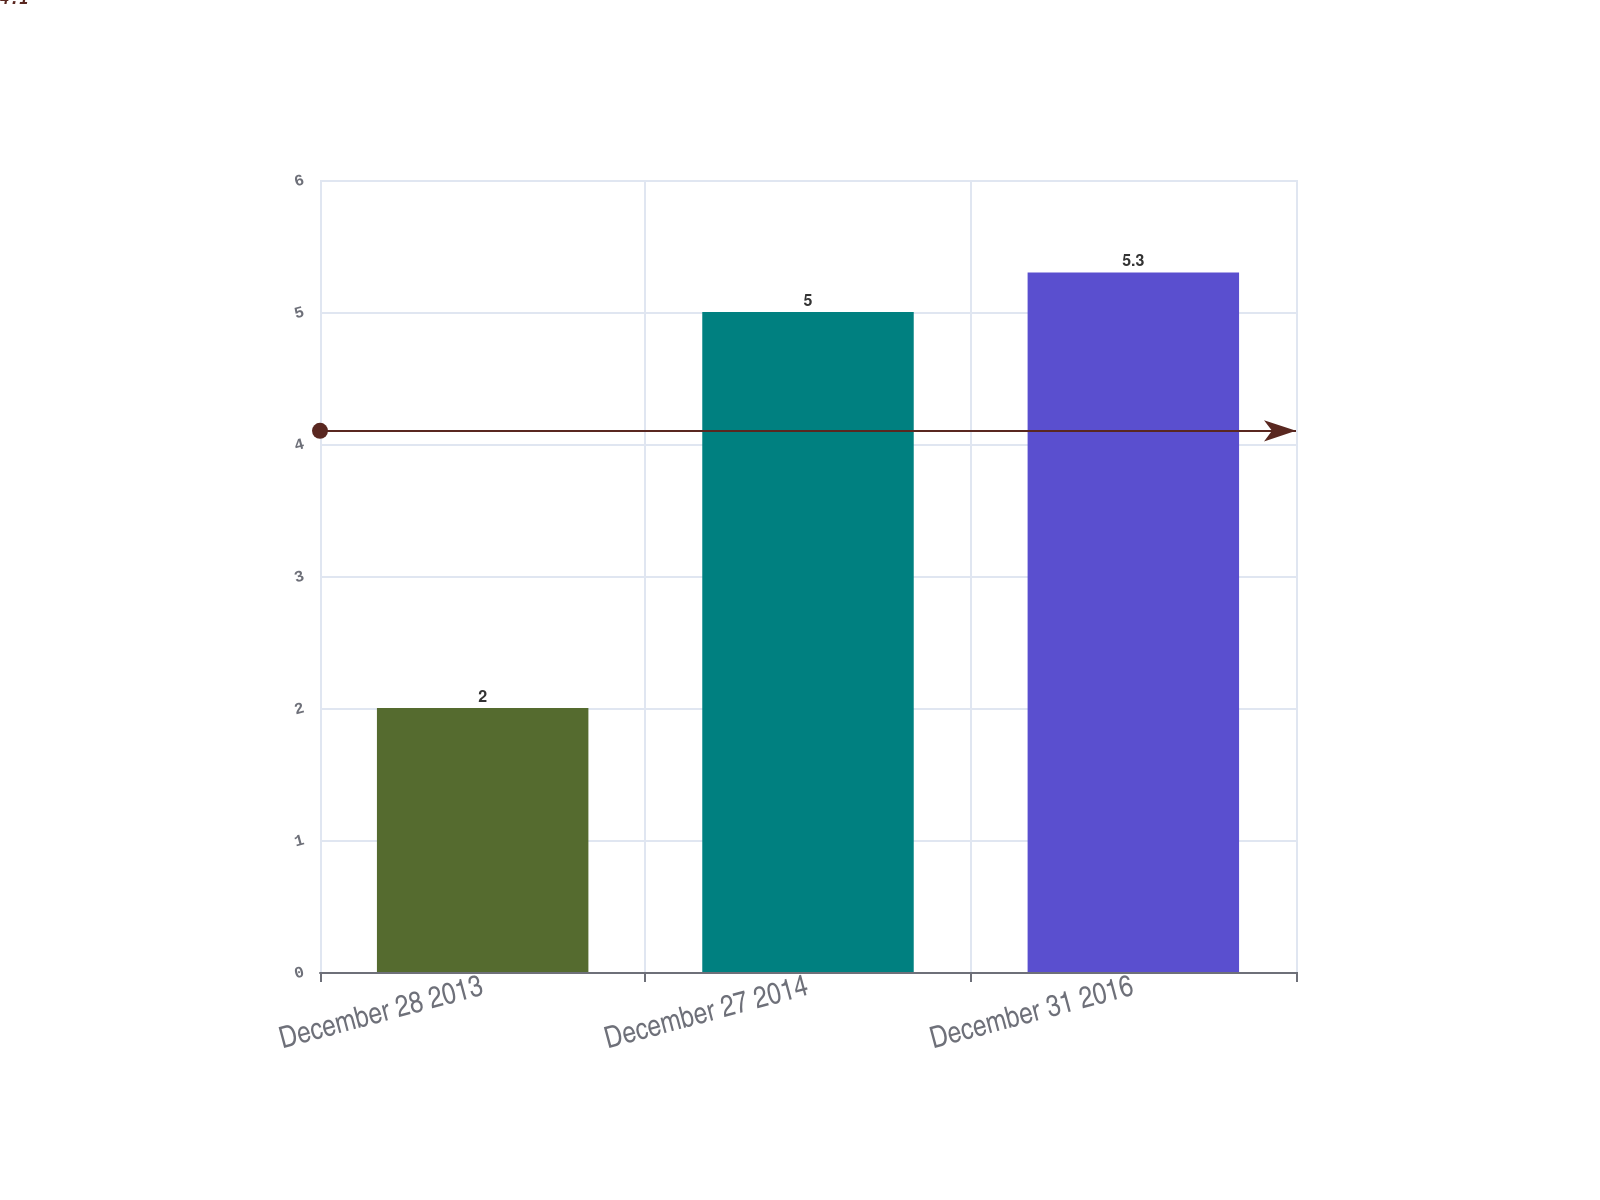Convert chart to OTSL. <chart><loc_0><loc_0><loc_500><loc_500><bar_chart><fcel>December 28 2013<fcel>December 27 2014<fcel>December 31 2016<nl><fcel>2<fcel>5<fcel>5.3<nl></chart> 